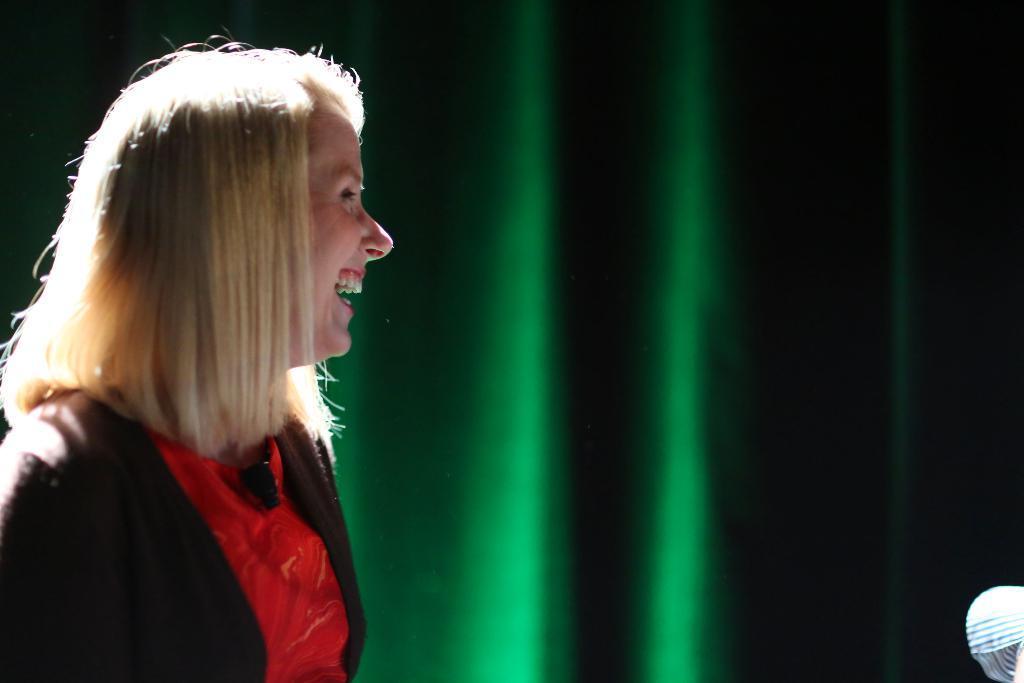Can you describe this image briefly? In this image, we can see a person wearing clothes. 